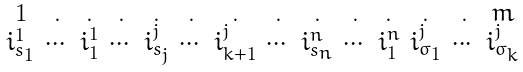<formula> <loc_0><loc_0><loc_500><loc_500>\begin{smallmatrix} 1 & . & . & . & . & . & . & . & . & . & . & . & . & m \\ i _ { s _ { 1 } } ^ { 1 } & \cdots & i _ { 1 } ^ { 1 } & \cdots & i _ { s _ { j } } ^ { j } & \cdots & i _ { k + 1 } ^ { j } & \cdots & i _ { s _ { n } } ^ { n } & \cdots & i _ { 1 } ^ { n } & i _ { \sigma _ { 1 } } ^ { j } & \cdots & i _ { \sigma _ { k } } ^ { j } \end{smallmatrix}</formula> 